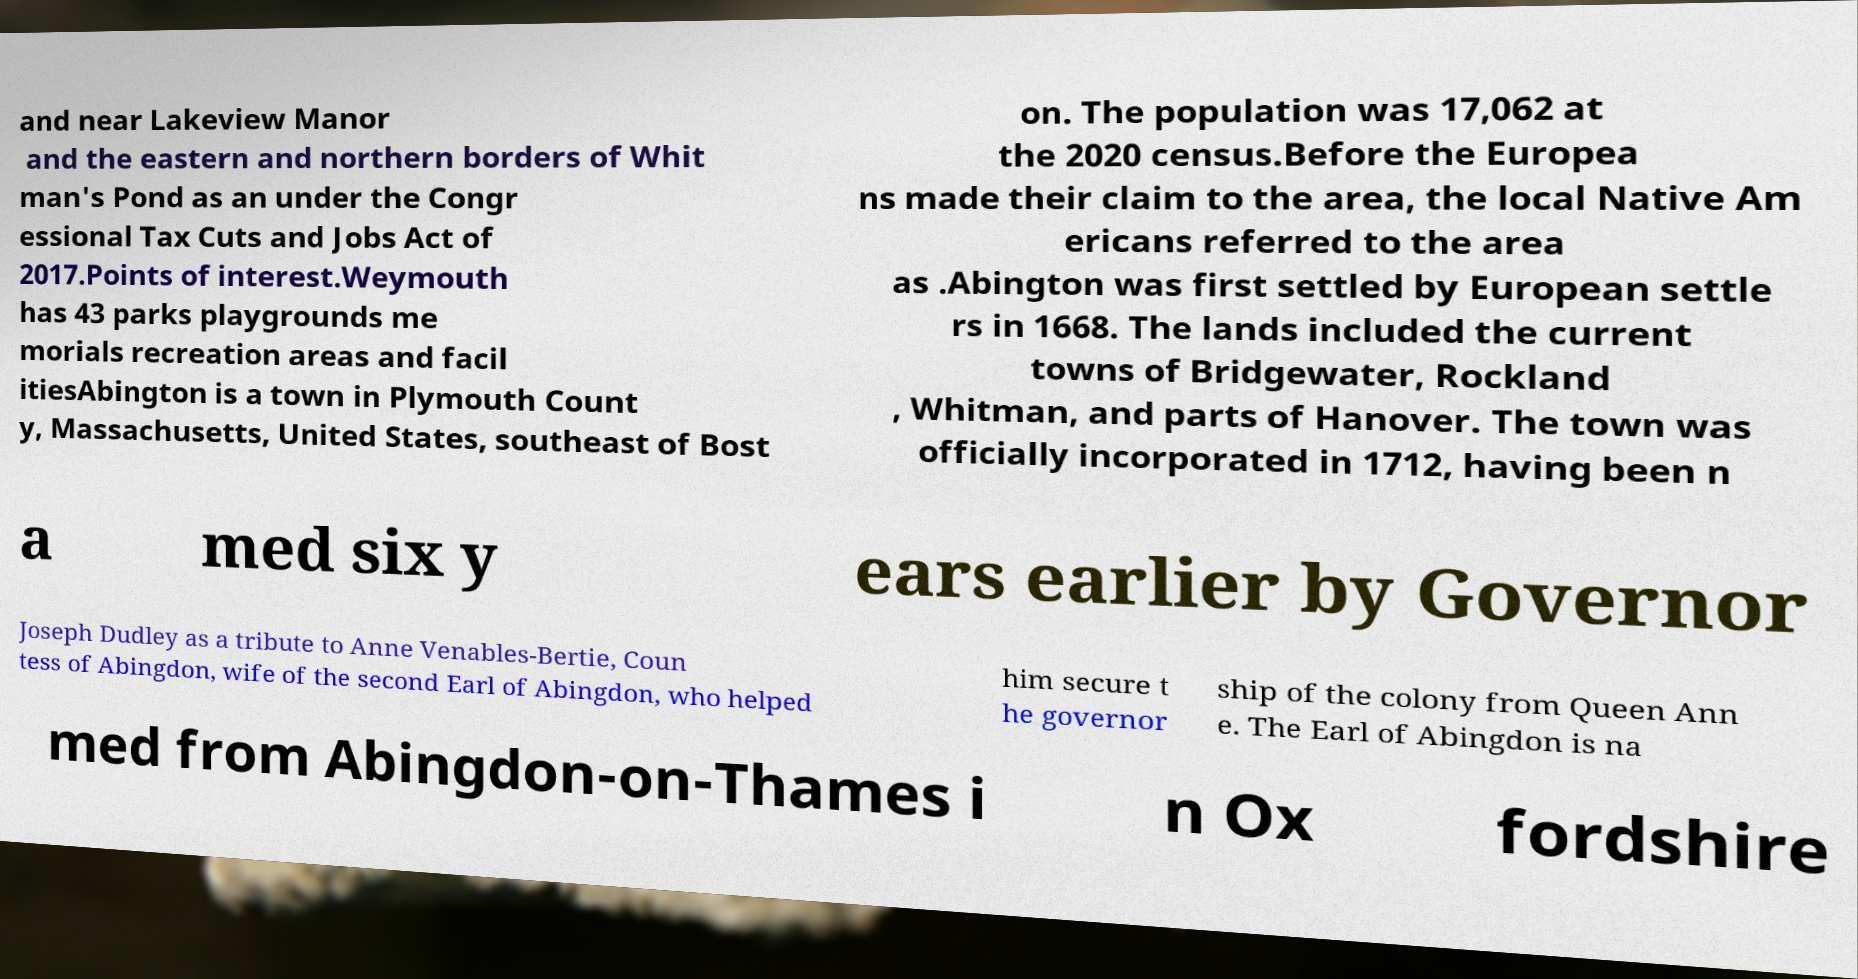What messages or text are displayed in this image? I need them in a readable, typed format. and near Lakeview Manor and the eastern and northern borders of Whit man's Pond as an under the Congr essional Tax Cuts and Jobs Act of 2017.Points of interest.Weymouth has 43 parks playgrounds me morials recreation areas and facil itiesAbington is a town in Plymouth Count y, Massachusetts, United States, southeast of Bost on. The population was 17,062 at the 2020 census.Before the Europea ns made their claim to the area, the local Native Am ericans referred to the area as .Abington was first settled by European settle rs in 1668. The lands included the current towns of Bridgewater, Rockland , Whitman, and parts of Hanover. The town was officially incorporated in 1712, having been n a med six y ears earlier by Governor Joseph Dudley as a tribute to Anne Venables-Bertie, Coun tess of Abingdon, wife of the second Earl of Abingdon, who helped him secure t he governor ship of the colony from Queen Ann e. The Earl of Abingdon is na med from Abingdon-on-Thames i n Ox fordshire 